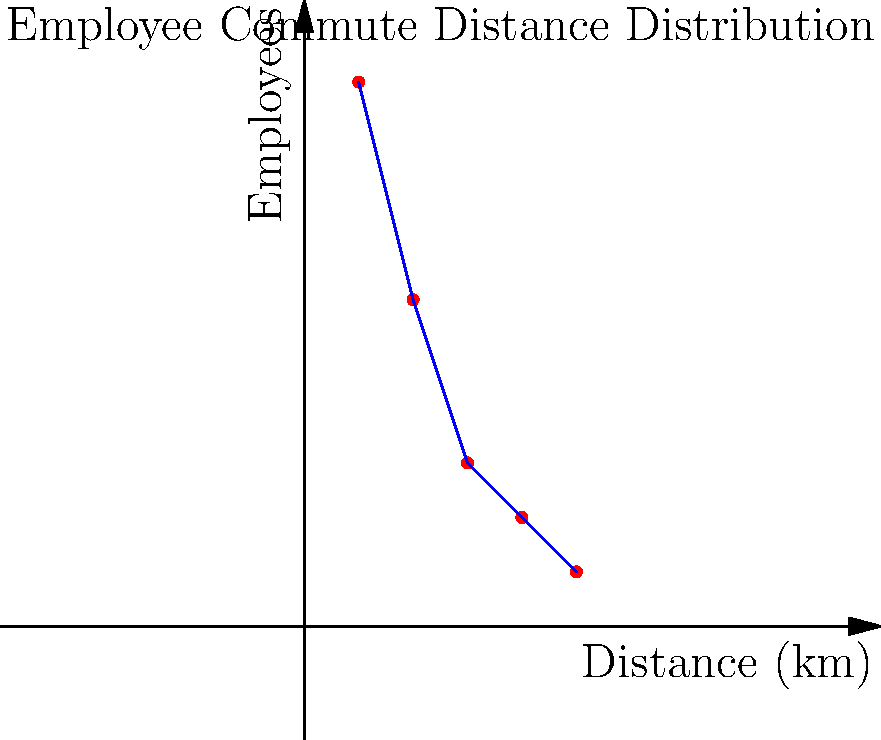A manufacturing company is implementing a green transportation plan to reduce its carbon footprint. The graph shows the distribution of employee commute distances. If the average carbon emission per employee is 0.2 kg CO₂/km and the company implements a plan that reduces this by 30% for all employees living within 15 km, what is the total daily carbon footprint reduction in kg CO₂ for a round trip commute? To solve this problem, we'll follow these steps:

1. Identify the number of employees within 15 km:
   - 0-5 km: 50 employees
   - 5-10 km: 30 employees
   - 10-15 km: 15 employees
   Total: 50 + 30 + 15 = 95 employees

2. Calculate the average commute distance for these employees:
   $\frac{(2.5 \times 50) + (7.5 \times 30) + (12.5 \times 15)}{95} = 5.92$ km

3. Calculate the total daily commute distance for affected employees:
   $5.92 \times 95 \times 2 = 1,124.8$ km (round trip)

4. Calculate the current daily carbon emissions for affected employees:
   $1,124.8 \times 0.2 = 224.96$ kg CO₂

5. Calculate the reduced carbon emissions after implementing the plan:
   $224.96 \times (1 - 0.30) = 157.472$ kg CO₂

6. Calculate the total daily carbon footprint reduction:
   $224.96 - 157.472 = 67.488$ kg CO₂
Answer: 67.49 kg CO₂ 